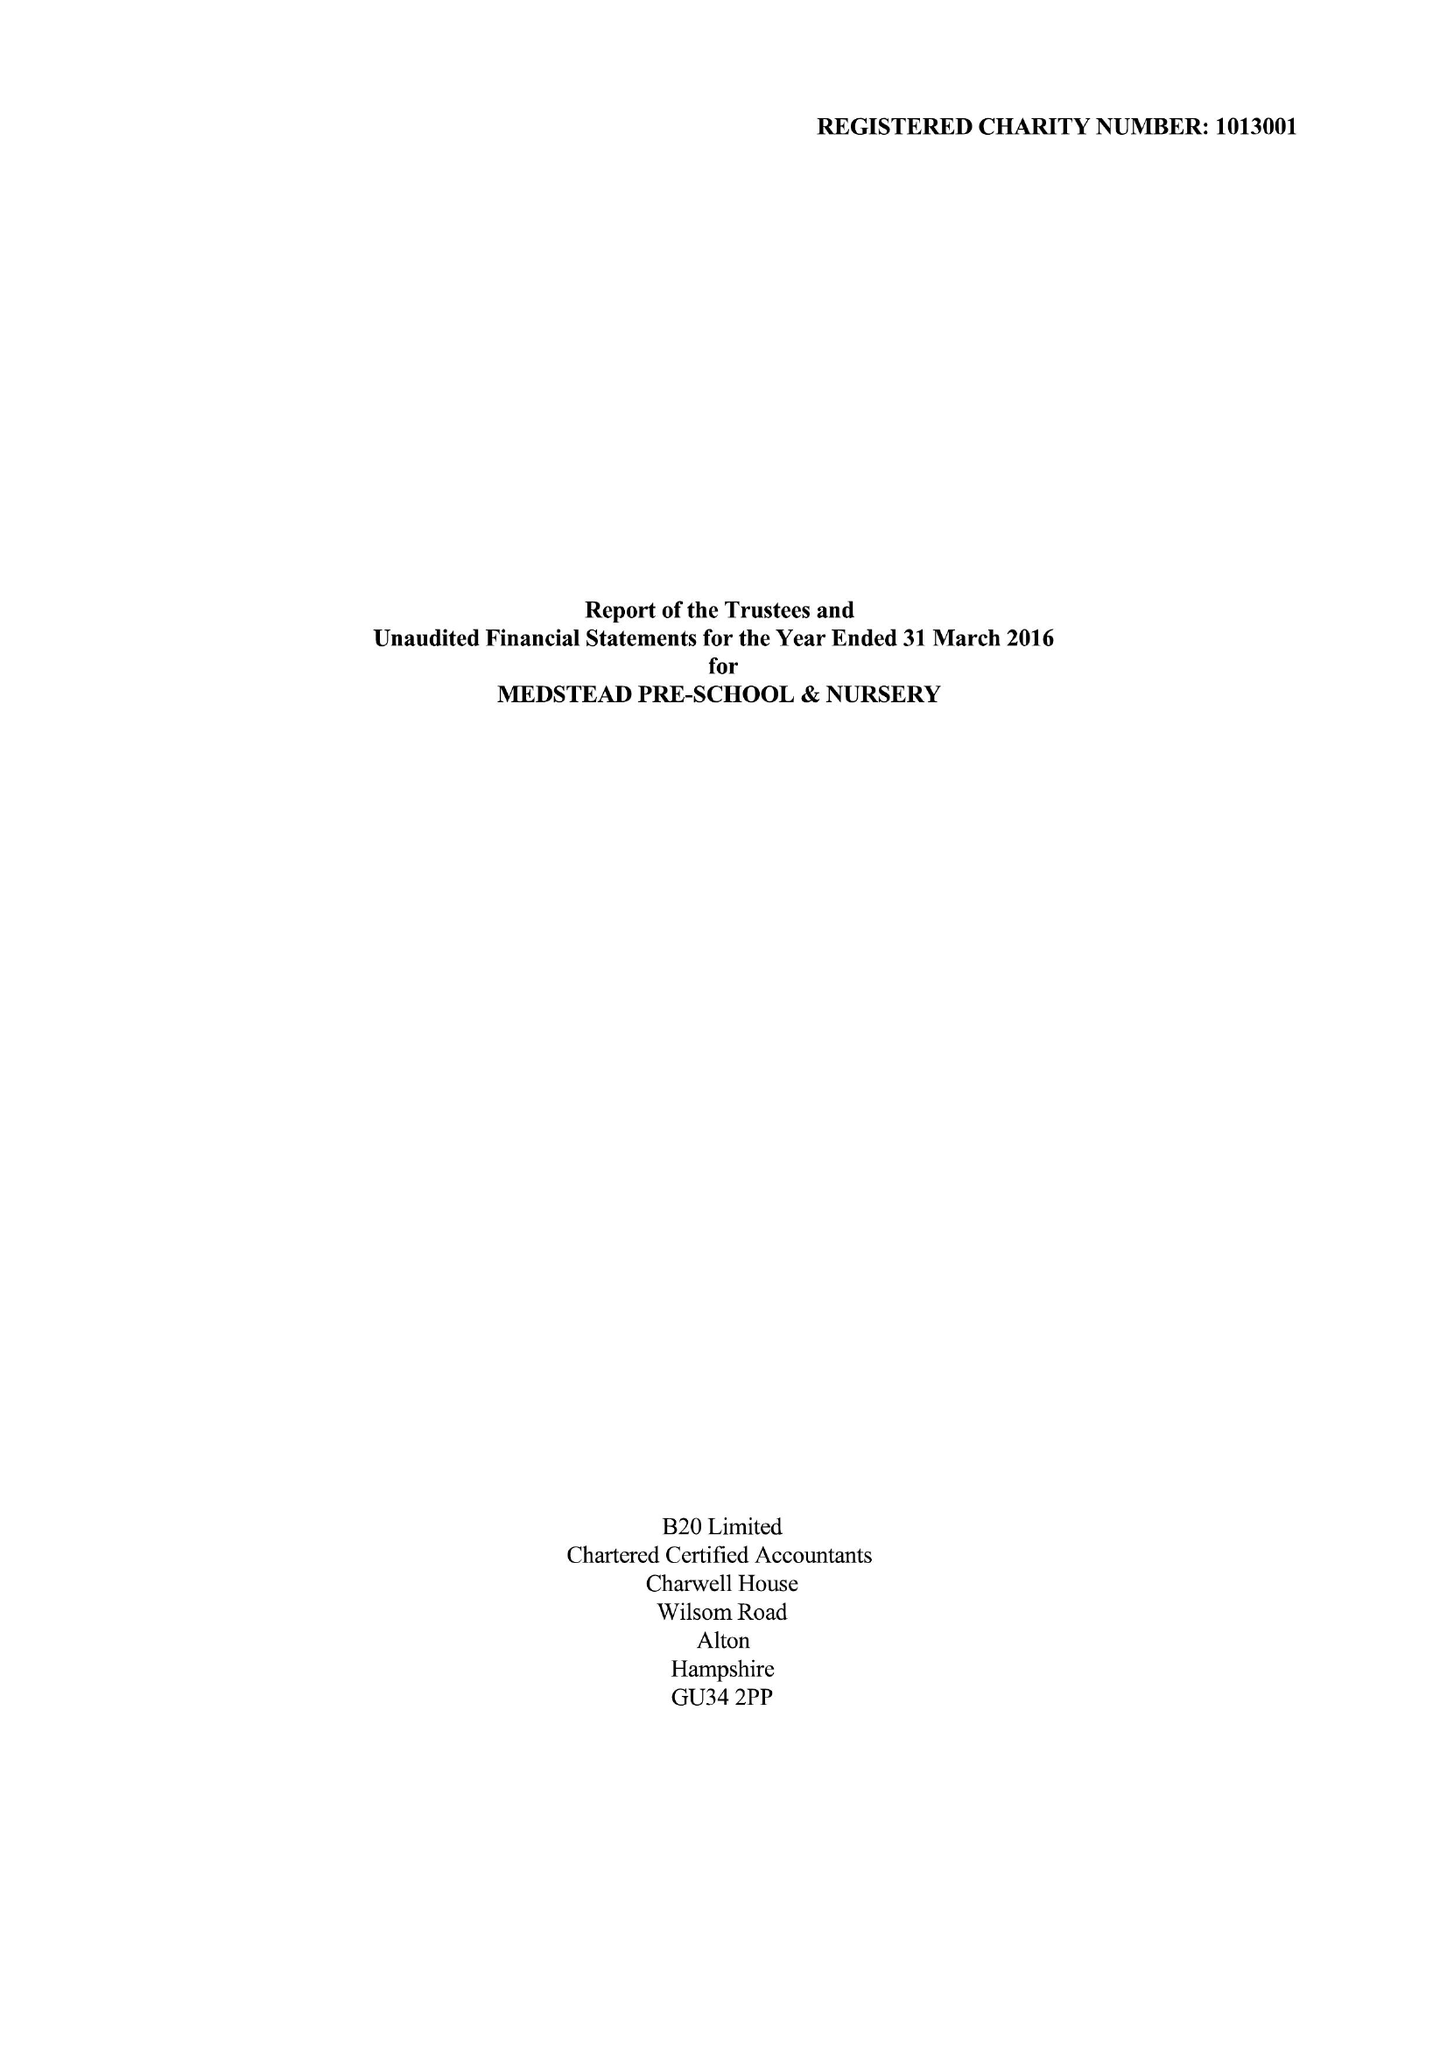What is the value for the address__postcode?
Answer the question using a single word or phrase. GU34 5LG 